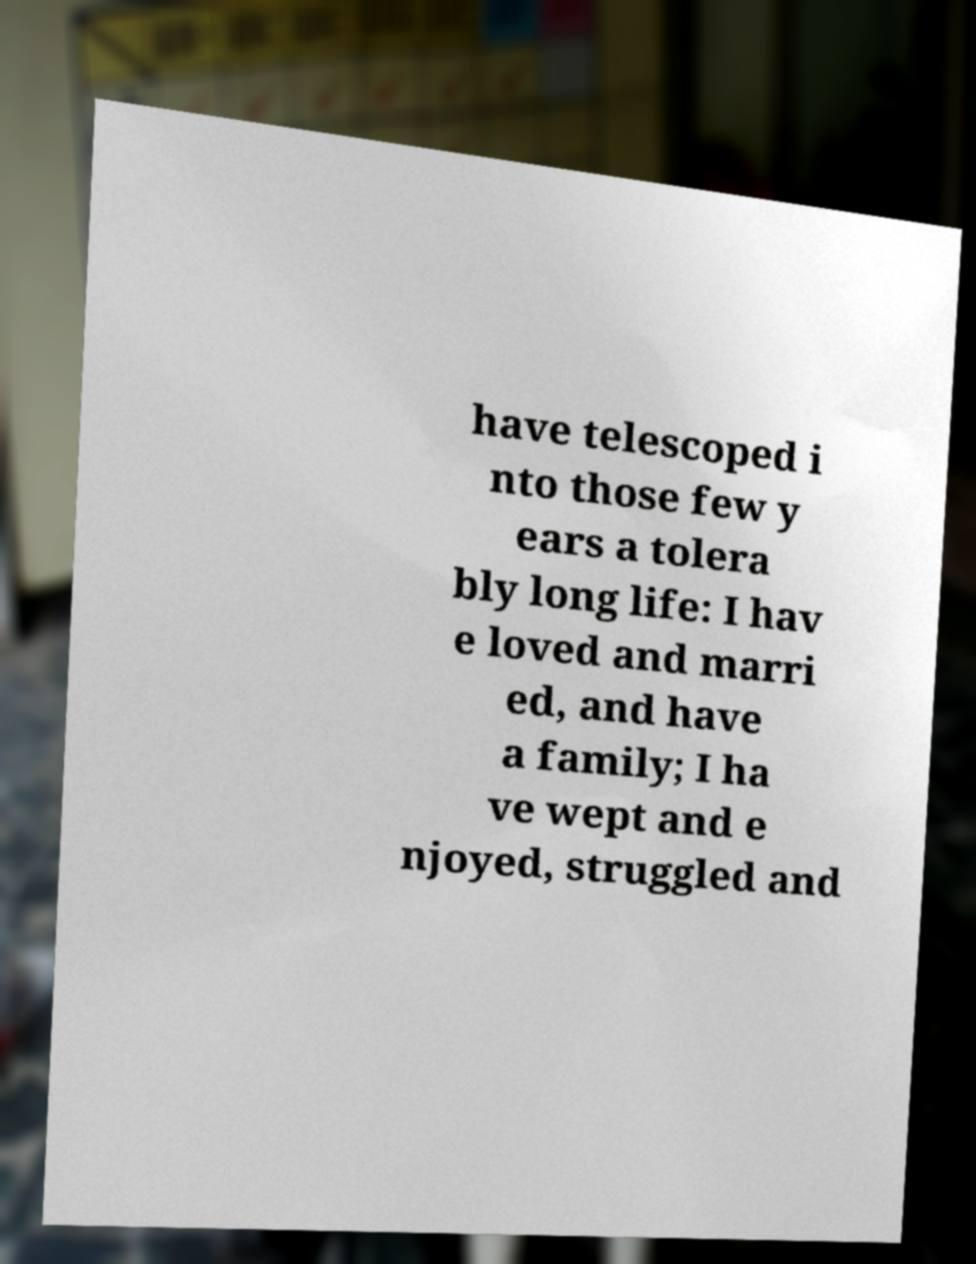Could you assist in decoding the text presented in this image and type it out clearly? have telescoped i nto those few y ears a tolera bly long life: I hav e loved and marri ed, and have a family; I ha ve wept and e njoyed, struggled and 